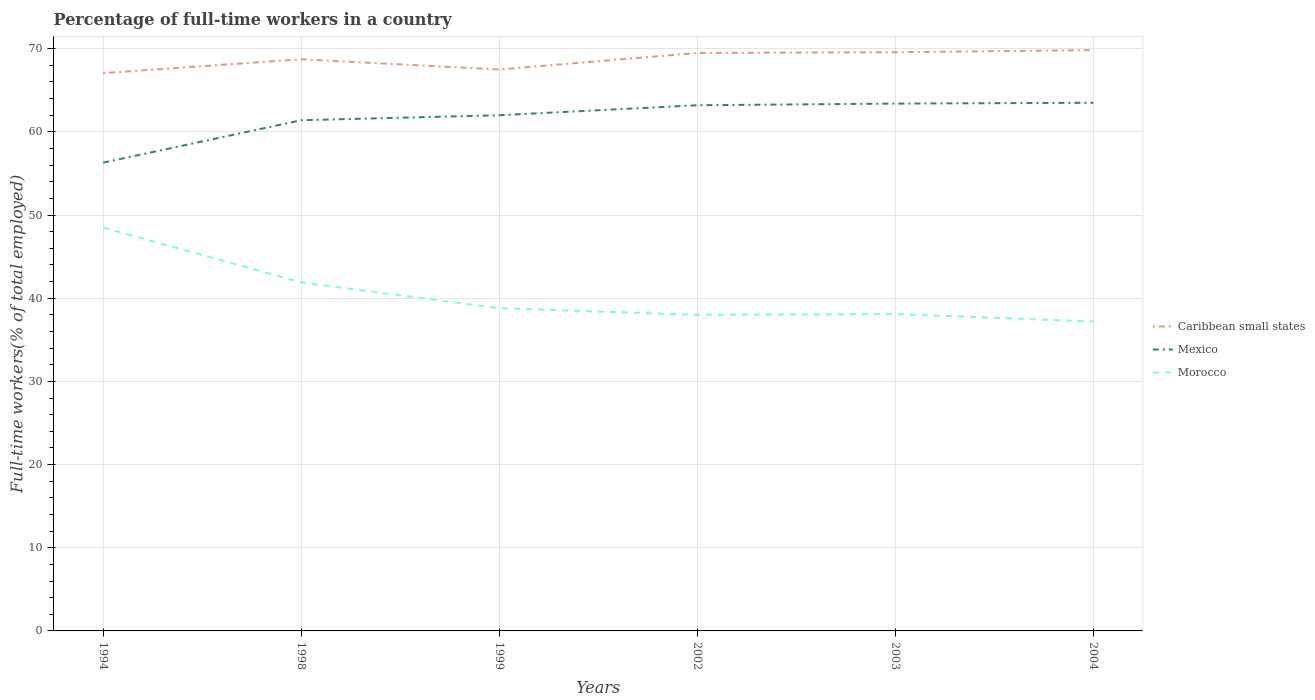How many different coloured lines are there?
Provide a short and direct response. 3. Does the line corresponding to Morocco intersect with the line corresponding to Caribbean small states?
Your answer should be very brief. No. Across all years, what is the maximum percentage of full-time workers in Caribbean small states?
Offer a very short reply. 67.06. In which year was the percentage of full-time workers in Morocco maximum?
Offer a terse response. 2004. What is the total percentage of full-time workers in Morocco in the graph?
Keep it short and to the point. 6.6. What is the difference between the highest and the second highest percentage of full-time workers in Mexico?
Provide a succinct answer. 7.2. What is the difference between the highest and the lowest percentage of full-time workers in Mexico?
Offer a very short reply. 4. How many years are there in the graph?
Your answer should be very brief. 6. What is the difference between two consecutive major ticks on the Y-axis?
Keep it short and to the point. 10. Are the values on the major ticks of Y-axis written in scientific E-notation?
Give a very brief answer. No. Does the graph contain any zero values?
Ensure brevity in your answer.  No. How many legend labels are there?
Make the answer very short. 3. How are the legend labels stacked?
Give a very brief answer. Vertical. What is the title of the graph?
Make the answer very short. Percentage of full-time workers in a country. Does "Greenland" appear as one of the legend labels in the graph?
Your response must be concise. No. What is the label or title of the Y-axis?
Your answer should be very brief. Full-time workers(% of total employed). What is the Full-time workers(% of total employed) in Caribbean small states in 1994?
Make the answer very short. 67.06. What is the Full-time workers(% of total employed) of Mexico in 1994?
Offer a terse response. 56.3. What is the Full-time workers(% of total employed) of Morocco in 1994?
Make the answer very short. 48.5. What is the Full-time workers(% of total employed) in Caribbean small states in 1998?
Ensure brevity in your answer.  68.73. What is the Full-time workers(% of total employed) of Mexico in 1998?
Your response must be concise. 61.4. What is the Full-time workers(% of total employed) in Morocco in 1998?
Ensure brevity in your answer.  41.9. What is the Full-time workers(% of total employed) of Caribbean small states in 1999?
Your response must be concise. 67.5. What is the Full-time workers(% of total employed) of Morocco in 1999?
Provide a short and direct response. 38.8. What is the Full-time workers(% of total employed) of Caribbean small states in 2002?
Make the answer very short. 69.49. What is the Full-time workers(% of total employed) of Mexico in 2002?
Offer a very short reply. 63.2. What is the Full-time workers(% of total employed) in Morocco in 2002?
Provide a short and direct response. 38. What is the Full-time workers(% of total employed) of Caribbean small states in 2003?
Ensure brevity in your answer.  69.57. What is the Full-time workers(% of total employed) of Mexico in 2003?
Provide a succinct answer. 63.4. What is the Full-time workers(% of total employed) of Morocco in 2003?
Ensure brevity in your answer.  38.1. What is the Full-time workers(% of total employed) of Caribbean small states in 2004?
Your answer should be very brief. 69.83. What is the Full-time workers(% of total employed) in Mexico in 2004?
Ensure brevity in your answer.  63.5. What is the Full-time workers(% of total employed) of Morocco in 2004?
Ensure brevity in your answer.  37.2. Across all years, what is the maximum Full-time workers(% of total employed) in Caribbean small states?
Your answer should be compact. 69.83. Across all years, what is the maximum Full-time workers(% of total employed) in Mexico?
Your response must be concise. 63.5. Across all years, what is the maximum Full-time workers(% of total employed) in Morocco?
Ensure brevity in your answer.  48.5. Across all years, what is the minimum Full-time workers(% of total employed) in Caribbean small states?
Provide a short and direct response. 67.06. Across all years, what is the minimum Full-time workers(% of total employed) in Mexico?
Make the answer very short. 56.3. Across all years, what is the minimum Full-time workers(% of total employed) in Morocco?
Give a very brief answer. 37.2. What is the total Full-time workers(% of total employed) in Caribbean small states in the graph?
Provide a succinct answer. 412.18. What is the total Full-time workers(% of total employed) in Mexico in the graph?
Your response must be concise. 369.8. What is the total Full-time workers(% of total employed) of Morocco in the graph?
Your answer should be very brief. 242.5. What is the difference between the Full-time workers(% of total employed) of Caribbean small states in 1994 and that in 1998?
Your response must be concise. -1.66. What is the difference between the Full-time workers(% of total employed) of Mexico in 1994 and that in 1998?
Offer a terse response. -5.1. What is the difference between the Full-time workers(% of total employed) in Caribbean small states in 1994 and that in 1999?
Keep it short and to the point. -0.44. What is the difference between the Full-time workers(% of total employed) in Caribbean small states in 1994 and that in 2002?
Ensure brevity in your answer.  -2.42. What is the difference between the Full-time workers(% of total employed) of Morocco in 1994 and that in 2002?
Your response must be concise. 10.5. What is the difference between the Full-time workers(% of total employed) in Caribbean small states in 1994 and that in 2003?
Ensure brevity in your answer.  -2.51. What is the difference between the Full-time workers(% of total employed) of Morocco in 1994 and that in 2003?
Give a very brief answer. 10.4. What is the difference between the Full-time workers(% of total employed) in Caribbean small states in 1994 and that in 2004?
Make the answer very short. -2.76. What is the difference between the Full-time workers(% of total employed) in Caribbean small states in 1998 and that in 1999?
Your answer should be very brief. 1.23. What is the difference between the Full-time workers(% of total employed) of Mexico in 1998 and that in 1999?
Provide a succinct answer. -0.6. What is the difference between the Full-time workers(% of total employed) of Morocco in 1998 and that in 1999?
Your answer should be very brief. 3.1. What is the difference between the Full-time workers(% of total employed) of Caribbean small states in 1998 and that in 2002?
Offer a very short reply. -0.76. What is the difference between the Full-time workers(% of total employed) of Morocco in 1998 and that in 2002?
Provide a succinct answer. 3.9. What is the difference between the Full-time workers(% of total employed) of Caribbean small states in 1998 and that in 2003?
Give a very brief answer. -0.84. What is the difference between the Full-time workers(% of total employed) of Mexico in 1998 and that in 2003?
Your answer should be very brief. -2. What is the difference between the Full-time workers(% of total employed) in Caribbean small states in 1998 and that in 2004?
Your answer should be compact. -1.1. What is the difference between the Full-time workers(% of total employed) of Morocco in 1998 and that in 2004?
Provide a succinct answer. 4.7. What is the difference between the Full-time workers(% of total employed) of Caribbean small states in 1999 and that in 2002?
Your answer should be compact. -1.99. What is the difference between the Full-time workers(% of total employed) in Caribbean small states in 1999 and that in 2003?
Offer a terse response. -2.07. What is the difference between the Full-time workers(% of total employed) of Caribbean small states in 1999 and that in 2004?
Give a very brief answer. -2.32. What is the difference between the Full-time workers(% of total employed) in Morocco in 1999 and that in 2004?
Your answer should be very brief. 1.6. What is the difference between the Full-time workers(% of total employed) of Caribbean small states in 2002 and that in 2003?
Offer a very short reply. -0.08. What is the difference between the Full-time workers(% of total employed) in Mexico in 2002 and that in 2003?
Provide a short and direct response. -0.2. What is the difference between the Full-time workers(% of total employed) of Morocco in 2002 and that in 2003?
Ensure brevity in your answer.  -0.1. What is the difference between the Full-time workers(% of total employed) of Caribbean small states in 2002 and that in 2004?
Your answer should be very brief. -0.34. What is the difference between the Full-time workers(% of total employed) of Mexico in 2002 and that in 2004?
Ensure brevity in your answer.  -0.3. What is the difference between the Full-time workers(% of total employed) of Morocco in 2002 and that in 2004?
Your response must be concise. 0.8. What is the difference between the Full-time workers(% of total employed) of Caribbean small states in 2003 and that in 2004?
Your response must be concise. -0.25. What is the difference between the Full-time workers(% of total employed) of Mexico in 2003 and that in 2004?
Provide a short and direct response. -0.1. What is the difference between the Full-time workers(% of total employed) in Caribbean small states in 1994 and the Full-time workers(% of total employed) in Mexico in 1998?
Offer a very short reply. 5.66. What is the difference between the Full-time workers(% of total employed) of Caribbean small states in 1994 and the Full-time workers(% of total employed) of Morocco in 1998?
Offer a very short reply. 25.16. What is the difference between the Full-time workers(% of total employed) in Mexico in 1994 and the Full-time workers(% of total employed) in Morocco in 1998?
Provide a succinct answer. 14.4. What is the difference between the Full-time workers(% of total employed) of Caribbean small states in 1994 and the Full-time workers(% of total employed) of Mexico in 1999?
Provide a succinct answer. 5.06. What is the difference between the Full-time workers(% of total employed) of Caribbean small states in 1994 and the Full-time workers(% of total employed) of Morocco in 1999?
Ensure brevity in your answer.  28.26. What is the difference between the Full-time workers(% of total employed) in Mexico in 1994 and the Full-time workers(% of total employed) in Morocco in 1999?
Keep it short and to the point. 17.5. What is the difference between the Full-time workers(% of total employed) of Caribbean small states in 1994 and the Full-time workers(% of total employed) of Mexico in 2002?
Your answer should be compact. 3.86. What is the difference between the Full-time workers(% of total employed) of Caribbean small states in 1994 and the Full-time workers(% of total employed) of Morocco in 2002?
Offer a very short reply. 29.06. What is the difference between the Full-time workers(% of total employed) of Caribbean small states in 1994 and the Full-time workers(% of total employed) of Mexico in 2003?
Provide a short and direct response. 3.66. What is the difference between the Full-time workers(% of total employed) of Caribbean small states in 1994 and the Full-time workers(% of total employed) of Morocco in 2003?
Offer a terse response. 28.96. What is the difference between the Full-time workers(% of total employed) in Caribbean small states in 1994 and the Full-time workers(% of total employed) in Mexico in 2004?
Your answer should be very brief. 3.56. What is the difference between the Full-time workers(% of total employed) in Caribbean small states in 1994 and the Full-time workers(% of total employed) in Morocco in 2004?
Offer a terse response. 29.86. What is the difference between the Full-time workers(% of total employed) of Mexico in 1994 and the Full-time workers(% of total employed) of Morocco in 2004?
Keep it short and to the point. 19.1. What is the difference between the Full-time workers(% of total employed) in Caribbean small states in 1998 and the Full-time workers(% of total employed) in Mexico in 1999?
Make the answer very short. 6.73. What is the difference between the Full-time workers(% of total employed) of Caribbean small states in 1998 and the Full-time workers(% of total employed) of Morocco in 1999?
Provide a succinct answer. 29.93. What is the difference between the Full-time workers(% of total employed) in Mexico in 1998 and the Full-time workers(% of total employed) in Morocco in 1999?
Provide a succinct answer. 22.6. What is the difference between the Full-time workers(% of total employed) in Caribbean small states in 1998 and the Full-time workers(% of total employed) in Mexico in 2002?
Your answer should be compact. 5.53. What is the difference between the Full-time workers(% of total employed) in Caribbean small states in 1998 and the Full-time workers(% of total employed) in Morocco in 2002?
Give a very brief answer. 30.73. What is the difference between the Full-time workers(% of total employed) of Mexico in 1998 and the Full-time workers(% of total employed) of Morocco in 2002?
Ensure brevity in your answer.  23.4. What is the difference between the Full-time workers(% of total employed) of Caribbean small states in 1998 and the Full-time workers(% of total employed) of Mexico in 2003?
Keep it short and to the point. 5.33. What is the difference between the Full-time workers(% of total employed) in Caribbean small states in 1998 and the Full-time workers(% of total employed) in Morocco in 2003?
Your response must be concise. 30.63. What is the difference between the Full-time workers(% of total employed) in Mexico in 1998 and the Full-time workers(% of total employed) in Morocco in 2003?
Offer a terse response. 23.3. What is the difference between the Full-time workers(% of total employed) of Caribbean small states in 1998 and the Full-time workers(% of total employed) of Mexico in 2004?
Offer a very short reply. 5.23. What is the difference between the Full-time workers(% of total employed) in Caribbean small states in 1998 and the Full-time workers(% of total employed) in Morocco in 2004?
Your answer should be very brief. 31.53. What is the difference between the Full-time workers(% of total employed) of Mexico in 1998 and the Full-time workers(% of total employed) of Morocco in 2004?
Your response must be concise. 24.2. What is the difference between the Full-time workers(% of total employed) of Caribbean small states in 1999 and the Full-time workers(% of total employed) of Mexico in 2002?
Your response must be concise. 4.3. What is the difference between the Full-time workers(% of total employed) in Caribbean small states in 1999 and the Full-time workers(% of total employed) in Morocco in 2002?
Offer a very short reply. 29.5. What is the difference between the Full-time workers(% of total employed) of Caribbean small states in 1999 and the Full-time workers(% of total employed) of Mexico in 2003?
Your answer should be very brief. 4.1. What is the difference between the Full-time workers(% of total employed) of Caribbean small states in 1999 and the Full-time workers(% of total employed) of Morocco in 2003?
Keep it short and to the point. 29.4. What is the difference between the Full-time workers(% of total employed) in Mexico in 1999 and the Full-time workers(% of total employed) in Morocco in 2003?
Your answer should be very brief. 23.9. What is the difference between the Full-time workers(% of total employed) in Caribbean small states in 1999 and the Full-time workers(% of total employed) in Mexico in 2004?
Ensure brevity in your answer.  4. What is the difference between the Full-time workers(% of total employed) in Caribbean small states in 1999 and the Full-time workers(% of total employed) in Morocco in 2004?
Your answer should be very brief. 30.3. What is the difference between the Full-time workers(% of total employed) of Mexico in 1999 and the Full-time workers(% of total employed) of Morocco in 2004?
Offer a terse response. 24.8. What is the difference between the Full-time workers(% of total employed) of Caribbean small states in 2002 and the Full-time workers(% of total employed) of Mexico in 2003?
Keep it short and to the point. 6.09. What is the difference between the Full-time workers(% of total employed) in Caribbean small states in 2002 and the Full-time workers(% of total employed) in Morocco in 2003?
Your answer should be compact. 31.39. What is the difference between the Full-time workers(% of total employed) of Mexico in 2002 and the Full-time workers(% of total employed) of Morocco in 2003?
Give a very brief answer. 25.1. What is the difference between the Full-time workers(% of total employed) in Caribbean small states in 2002 and the Full-time workers(% of total employed) in Mexico in 2004?
Provide a succinct answer. 5.99. What is the difference between the Full-time workers(% of total employed) in Caribbean small states in 2002 and the Full-time workers(% of total employed) in Morocco in 2004?
Offer a very short reply. 32.29. What is the difference between the Full-time workers(% of total employed) in Mexico in 2002 and the Full-time workers(% of total employed) in Morocco in 2004?
Ensure brevity in your answer.  26. What is the difference between the Full-time workers(% of total employed) of Caribbean small states in 2003 and the Full-time workers(% of total employed) of Mexico in 2004?
Offer a very short reply. 6.07. What is the difference between the Full-time workers(% of total employed) of Caribbean small states in 2003 and the Full-time workers(% of total employed) of Morocco in 2004?
Provide a succinct answer. 32.37. What is the difference between the Full-time workers(% of total employed) of Mexico in 2003 and the Full-time workers(% of total employed) of Morocco in 2004?
Your answer should be very brief. 26.2. What is the average Full-time workers(% of total employed) in Caribbean small states per year?
Offer a very short reply. 68.7. What is the average Full-time workers(% of total employed) in Mexico per year?
Make the answer very short. 61.63. What is the average Full-time workers(% of total employed) of Morocco per year?
Offer a very short reply. 40.42. In the year 1994, what is the difference between the Full-time workers(% of total employed) in Caribbean small states and Full-time workers(% of total employed) in Mexico?
Make the answer very short. 10.76. In the year 1994, what is the difference between the Full-time workers(% of total employed) in Caribbean small states and Full-time workers(% of total employed) in Morocco?
Your answer should be very brief. 18.56. In the year 1994, what is the difference between the Full-time workers(% of total employed) of Mexico and Full-time workers(% of total employed) of Morocco?
Your answer should be compact. 7.8. In the year 1998, what is the difference between the Full-time workers(% of total employed) in Caribbean small states and Full-time workers(% of total employed) in Mexico?
Make the answer very short. 7.33. In the year 1998, what is the difference between the Full-time workers(% of total employed) of Caribbean small states and Full-time workers(% of total employed) of Morocco?
Your response must be concise. 26.83. In the year 1999, what is the difference between the Full-time workers(% of total employed) of Caribbean small states and Full-time workers(% of total employed) of Mexico?
Give a very brief answer. 5.5. In the year 1999, what is the difference between the Full-time workers(% of total employed) of Caribbean small states and Full-time workers(% of total employed) of Morocco?
Provide a succinct answer. 28.7. In the year 1999, what is the difference between the Full-time workers(% of total employed) of Mexico and Full-time workers(% of total employed) of Morocco?
Your answer should be very brief. 23.2. In the year 2002, what is the difference between the Full-time workers(% of total employed) of Caribbean small states and Full-time workers(% of total employed) of Mexico?
Your answer should be very brief. 6.29. In the year 2002, what is the difference between the Full-time workers(% of total employed) of Caribbean small states and Full-time workers(% of total employed) of Morocco?
Your answer should be very brief. 31.49. In the year 2002, what is the difference between the Full-time workers(% of total employed) of Mexico and Full-time workers(% of total employed) of Morocco?
Keep it short and to the point. 25.2. In the year 2003, what is the difference between the Full-time workers(% of total employed) in Caribbean small states and Full-time workers(% of total employed) in Mexico?
Provide a short and direct response. 6.17. In the year 2003, what is the difference between the Full-time workers(% of total employed) in Caribbean small states and Full-time workers(% of total employed) in Morocco?
Your response must be concise. 31.47. In the year 2003, what is the difference between the Full-time workers(% of total employed) in Mexico and Full-time workers(% of total employed) in Morocco?
Provide a short and direct response. 25.3. In the year 2004, what is the difference between the Full-time workers(% of total employed) of Caribbean small states and Full-time workers(% of total employed) of Mexico?
Your answer should be very brief. 6.33. In the year 2004, what is the difference between the Full-time workers(% of total employed) in Caribbean small states and Full-time workers(% of total employed) in Morocco?
Give a very brief answer. 32.63. In the year 2004, what is the difference between the Full-time workers(% of total employed) of Mexico and Full-time workers(% of total employed) of Morocco?
Keep it short and to the point. 26.3. What is the ratio of the Full-time workers(% of total employed) in Caribbean small states in 1994 to that in 1998?
Your answer should be compact. 0.98. What is the ratio of the Full-time workers(% of total employed) in Mexico in 1994 to that in 1998?
Your answer should be very brief. 0.92. What is the ratio of the Full-time workers(% of total employed) of Morocco in 1994 to that in 1998?
Provide a succinct answer. 1.16. What is the ratio of the Full-time workers(% of total employed) in Mexico in 1994 to that in 1999?
Keep it short and to the point. 0.91. What is the ratio of the Full-time workers(% of total employed) of Morocco in 1994 to that in 1999?
Your answer should be very brief. 1.25. What is the ratio of the Full-time workers(% of total employed) of Caribbean small states in 1994 to that in 2002?
Provide a short and direct response. 0.97. What is the ratio of the Full-time workers(% of total employed) of Mexico in 1994 to that in 2002?
Your answer should be very brief. 0.89. What is the ratio of the Full-time workers(% of total employed) in Morocco in 1994 to that in 2002?
Give a very brief answer. 1.28. What is the ratio of the Full-time workers(% of total employed) in Caribbean small states in 1994 to that in 2003?
Your response must be concise. 0.96. What is the ratio of the Full-time workers(% of total employed) in Mexico in 1994 to that in 2003?
Give a very brief answer. 0.89. What is the ratio of the Full-time workers(% of total employed) of Morocco in 1994 to that in 2003?
Keep it short and to the point. 1.27. What is the ratio of the Full-time workers(% of total employed) of Caribbean small states in 1994 to that in 2004?
Provide a short and direct response. 0.96. What is the ratio of the Full-time workers(% of total employed) in Mexico in 1994 to that in 2004?
Your answer should be very brief. 0.89. What is the ratio of the Full-time workers(% of total employed) of Morocco in 1994 to that in 2004?
Keep it short and to the point. 1.3. What is the ratio of the Full-time workers(% of total employed) of Caribbean small states in 1998 to that in 1999?
Offer a very short reply. 1.02. What is the ratio of the Full-time workers(% of total employed) of Mexico in 1998 to that in 1999?
Your answer should be compact. 0.99. What is the ratio of the Full-time workers(% of total employed) of Morocco in 1998 to that in 1999?
Ensure brevity in your answer.  1.08. What is the ratio of the Full-time workers(% of total employed) of Mexico in 1998 to that in 2002?
Your answer should be very brief. 0.97. What is the ratio of the Full-time workers(% of total employed) of Morocco in 1998 to that in 2002?
Your response must be concise. 1.1. What is the ratio of the Full-time workers(% of total employed) in Caribbean small states in 1998 to that in 2003?
Ensure brevity in your answer.  0.99. What is the ratio of the Full-time workers(% of total employed) of Mexico in 1998 to that in 2003?
Make the answer very short. 0.97. What is the ratio of the Full-time workers(% of total employed) of Morocco in 1998 to that in 2003?
Provide a short and direct response. 1.1. What is the ratio of the Full-time workers(% of total employed) of Caribbean small states in 1998 to that in 2004?
Make the answer very short. 0.98. What is the ratio of the Full-time workers(% of total employed) in Mexico in 1998 to that in 2004?
Offer a terse response. 0.97. What is the ratio of the Full-time workers(% of total employed) of Morocco in 1998 to that in 2004?
Provide a short and direct response. 1.13. What is the ratio of the Full-time workers(% of total employed) of Caribbean small states in 1999 to that in 2002?
Ensure brevity in your answer.  0.97. What is the ratio of the Full-time workers(% of total employed) in Mexico in 1999 to that in 2002?
Your answer should be compact. 0.98. What is the ratio of the Full-time workers(% of total employed) of Morocco in 1999 to that in 2002?
Your answer should be very brief. 1.02. What is the ratio of the Full-time workers(% of total employed) of Caribbean small states in 1999 to that in 2003?
Ensure brevity in your answer.  0.97. What is the ratio of the Full-time workers(% of total employed) of Mexico in 1999 to that in 2003?
Ensure brevity in your answer.  0.98. What is the ratio of the Full-time workers(% of total employed) of Morocco in 1999 to that in 2003?
Provide a succinct answer. 1.02. What is the ratio of the Full-time workers(% of total employed) in Caribbean small states in 1999 to that in 2004?
Your response must be concise. 0.97. What is the ratio of the Full-time workers(% of total employed) of Mexico in 1999 to that in 2004?
Your answer should be very brief. 0.98. What is the ratio of the Full-time workers(% of total employed) in Morocco in 1999 to that in 2004?
Provide a succinct answer. 1.04. What is the ratio of the Full-time workers(% of total employed) of Mexico in 2002 to that in 2003?
Ensure brevity in your answer.  1. What is the ratio of the Full-time workers(% of total employed) of Morocco in 2002 to that in 2003?
Make the answer very short. 1. What is the ratio of the Full-time workers(% of total employed) in Mexico in 2002 to that in 2004?
Provide a short and direct response. 1. What is the ratio of the Full-time workers(% of total employed) of Morocco in 2002 to that in 2004?
Your answer should be very brief. 1.02. What is the ratio of the Full-time workers(% of total employed) of Caribbean small states in 2003 to that in 2004?
Provide a short and direct response. 1. What is the ratio of the Full-time workers(% of total employed) of Morocco in 2003 to that in 2004?
Provide a succinct answer. 1.02. What is the difference between the highest and the second highest Full-time workers(% of total employed) of Caribbean small states?
Offer a terse response. 0.25. What is the difference between the highest and the lowest Full-time workers(% of total employed) in Caribbean small states?
Provide a succinct answer. 2.76. What is the difference between the highest and the lowest Full-time workers(% of total employed) in Mexico?
Offer a very short reply. 7.2. 